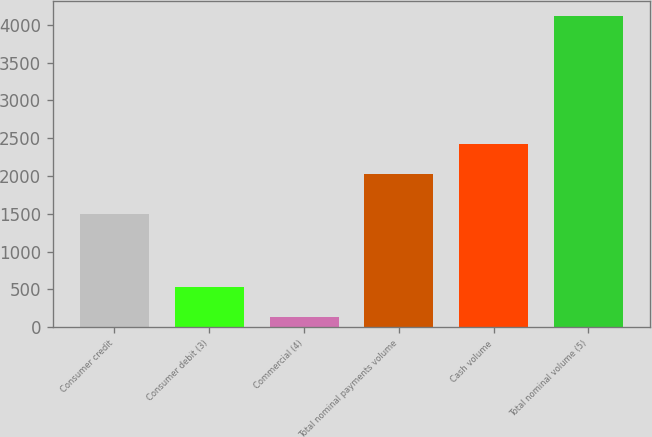Convert chart to OTSL. <chart><loc_0><loc_0><loc_500><loc_500><bar_chart><fcel>Consumer credit<fcel>Consumer debit (3)<fcel>Commercial (4)<fcel>Total nominal payments volume<fcel>Cash volume<fcel>Total nominal volume (5)<nl><fcel>1498<fcel>537.3<fcel>140<fcel>2030<fcel>2427.3<fcel>4113<nl></chart> 